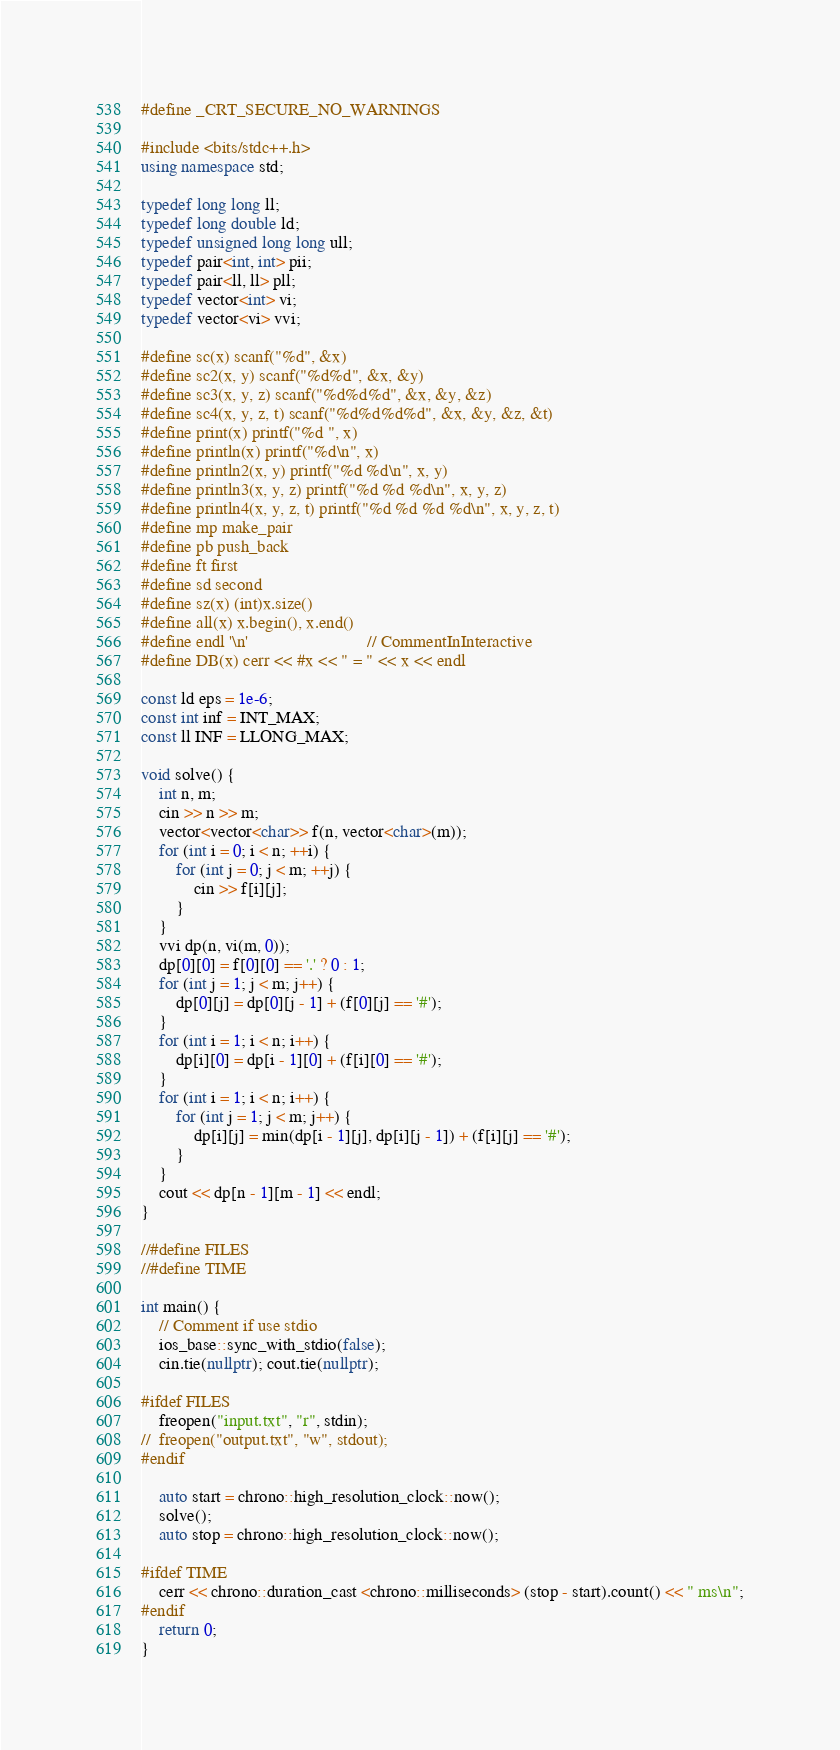Convert code to text. <code><loc_0><loc_0><loc_500><loc_500><_C++_>#define _CRT_SECURE_NO_WARNINGS

#include <bits/stdc++.h>
using namespace std;

typedef long long ll;
typedef long double ld;
typedef unsigned long long ull;
typedef pair<int, int> pii;
typedef pair<ll, ll> pll;
typedef vector<int> vi;
typedef vector<vi> vvi;

#define sc(x) scanf("%d", &x)
#define sc2(x, y) scanf("%d%d", &x, &y)
#define sc3(x, y, z) scanf("%d%d%d", &x, &y, &z)
#define sc4(x, y, z, t) scanf("%d%d%d%d", &x, &y, &z, &t)
#define print(x) printf("%d ", x)
#define println(x) printf("%d\n", x)
#define println2(x, y) printf("%d %d\n", x, y)
#define println3(x, y, z) printf("%d %d %d\n", x, y, z)
#define println4(x, y, z, t) printf("%d %d %d %d\n", x, y, z, t)
#define mp make_pair
#define pb push_back
#define ft first
#define sd second
#define sz(x) (int)x.size()
#define all(x) x.begin(), x.end()
#define endl '\n'                           // CommentInInteractive
#define DB(x) cerr << #x << " = " << x << endl

const ld eps = 1e-6;
const int inf = INT_MAX;
const ll INF = LLONG_MAX;

void solve() {
    int n, m;
    cin >> n >> m;
    vector<vector<char>> f(n, vector<char>(m));
    for (int i = 0; i < n; ++i) {
        for (int j = 0; j < m; ++j) {
            cin >> f[i][j];
        }
    }
    vvi dp(n, vi(m, 0));
    dp[0][0] = f[0][0] == '.' ? 0 : 1;
    for (int j = 1; j < m; j++) {
        dp[0][j] = dp[0][j - 1] + (f[0][j] == '#');
    }
    for (int i = 1; i < n; i++) {
        dp[i][0] = dp[i - 1][0] + (f[i][0] == '#');
    }
    for (int i = 1; i < n; i++) {
        for (int j = 1; j < m; j++) {
            dp[i][j] = min(dp[i - 1][j], dp[i][j - 1]) + (f[i][j] == '#');
        }
    }
    cout << dp[n - 1][m - 1] << endl;
}

//#define FILES
//#define TIME

int main() {
    // Comment if use stdio
    ios_base::sync_with_stdio(false);
    cin.tie(nullptr); cout.tie(nullptr);

#ifdef FILES
    freopen("input.txt", "r", stdin);
//	freopen("output.txt", "w", stdout);
#endif

    auto start = chrono::high_resolution_clock::now();
    solve();
    auto stop = chrono::high_resolution_clock::now();

#ifdef TIME
    cerr << chrono::duration_cast <chrono::milliseconds> (stop - start).count() << " ms\n";
#endif
    return 0;
}</code> 